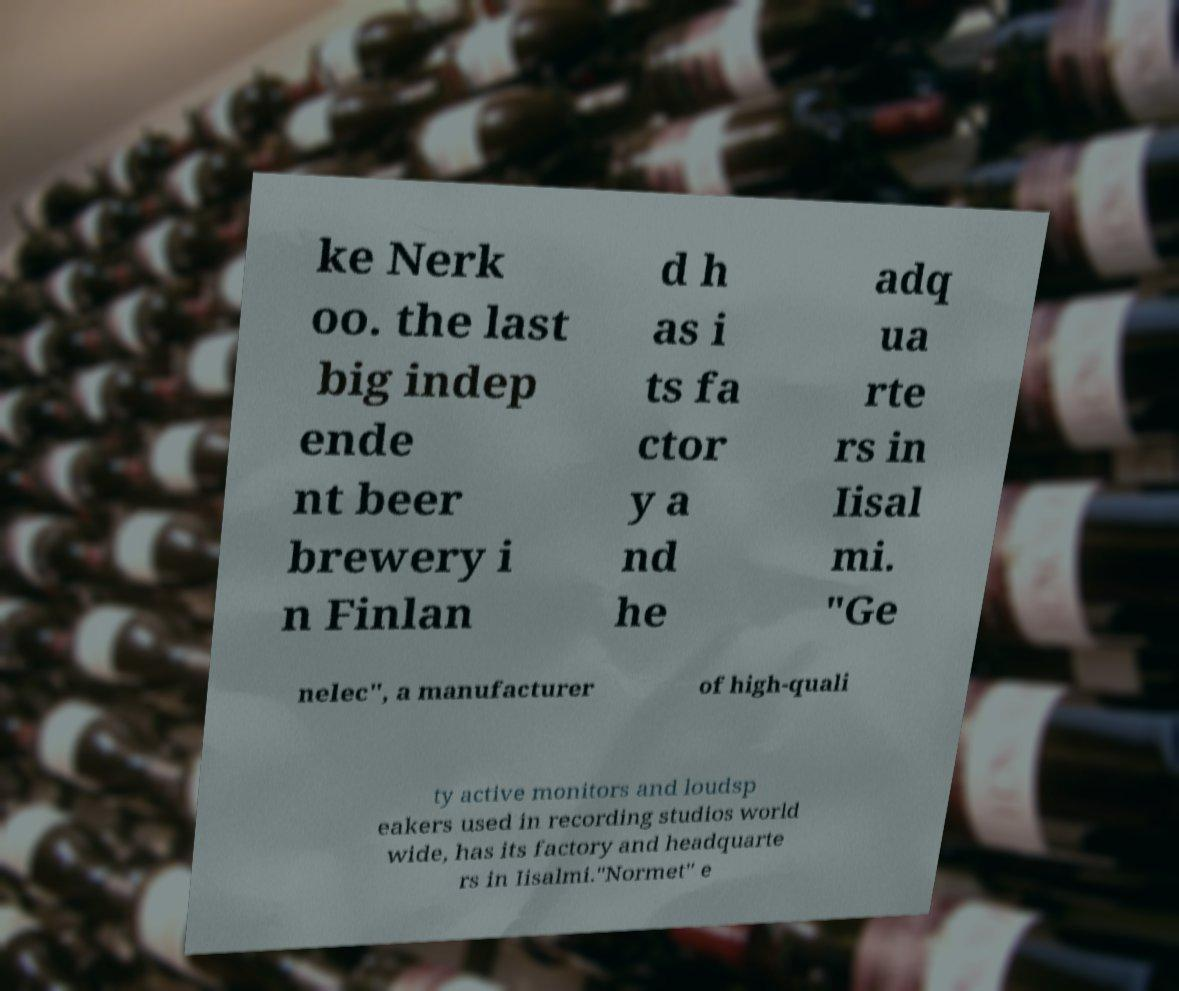What messages or text are displayed in this image? I need them in a readable, typed format. ke Nerk oo. the last big indep ende nt beer brewery i n Finlan d h as i ts fa ctor y a nd he adq ua rte rs in Iisal mi. "Ge nelec", a manufacturer of high-quali ty active monitors and loudsp eakers used in recording studios world wide, has its factory and headquarte rs in Iisalmi."Normet" e 